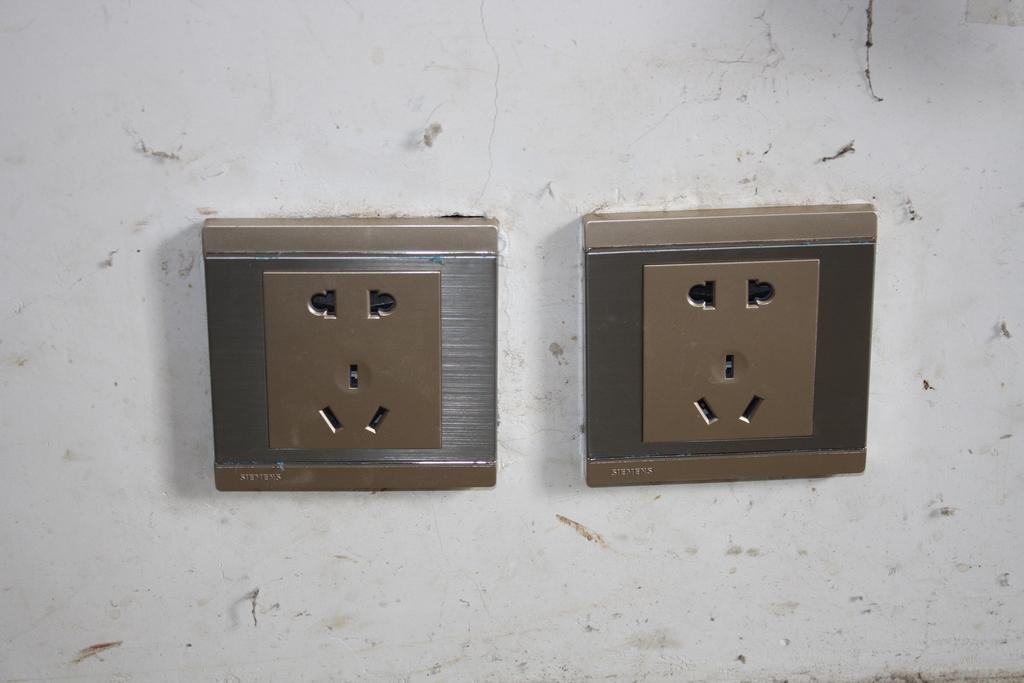How many socket boards are visible in the image? There are two socket boards in the image. Where are the socket boards located? The socket boards are attached to the wall. What type of business is being conducted in the image? There is no indication of any business being conducted in the image; it only features two socket boards attached to the wall. 